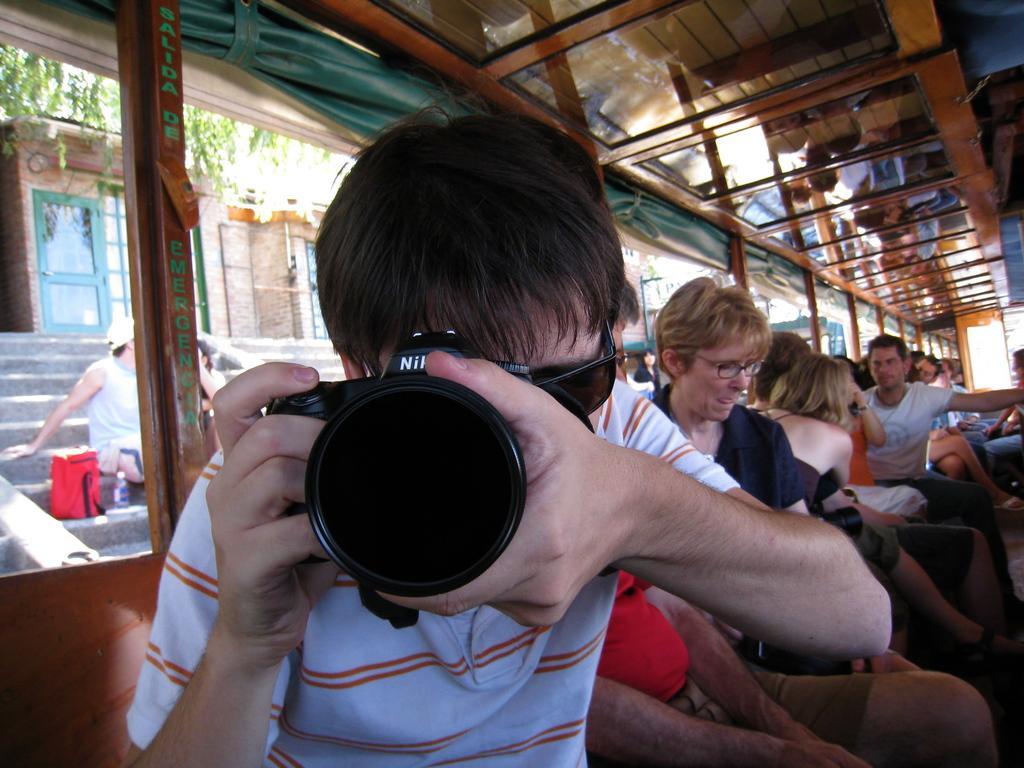How would you summarize this image in a sentence or two? In the image we can see there is a man who is holding a camera and behind him there are lot of people who are sitting and outside of the vehicle there's a man who is sitting on the stairs. 